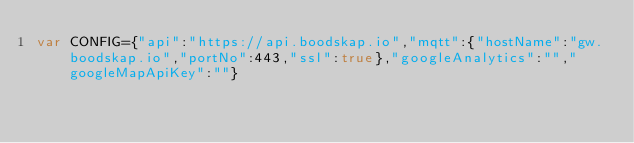<code> <loc_0><loc_0><loc_500><loc_500><_JavaScript_>var CONFIG={"api":"https://api.boodskap.io","mqtt":{"hostName":"gw.boodskap.io","portNo":443,"ssl":true},"googleAnalytics":"","googleMapApiKey":""}</code> 